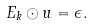<formula> <loc_0><loc_0><loc_500><loc_500>E _ { k } \odot u = \epsilon .</formula> 